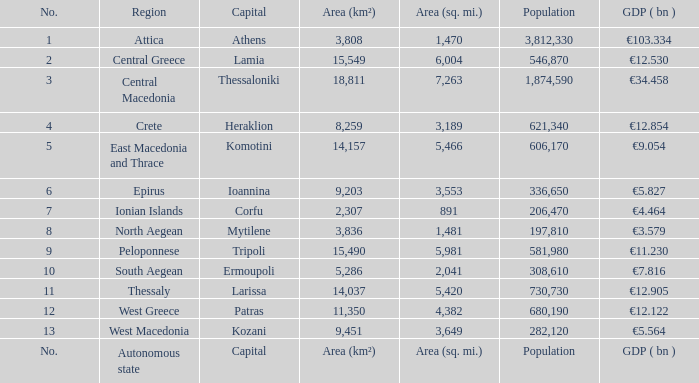What is the population where the area (sq. mi.) is area (sq. mi.)? Population. 